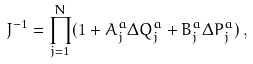<formula> <loc_0><loc_0><loc_500><loc_500>J ^ { - 1 } = \prod _ { j = 1 } ^ { N } ( 1 + A ^ { a } _ { j } \Delta Q ^ { a } _ { j } + B ^ { a } _ { j } \Delta P ^ { a } _ { j } ) \, ,</formula> 